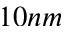Convert formula to latex. <formula><loc_0><loc_0><loc_500><loc_500>1 0 n m</formula> 